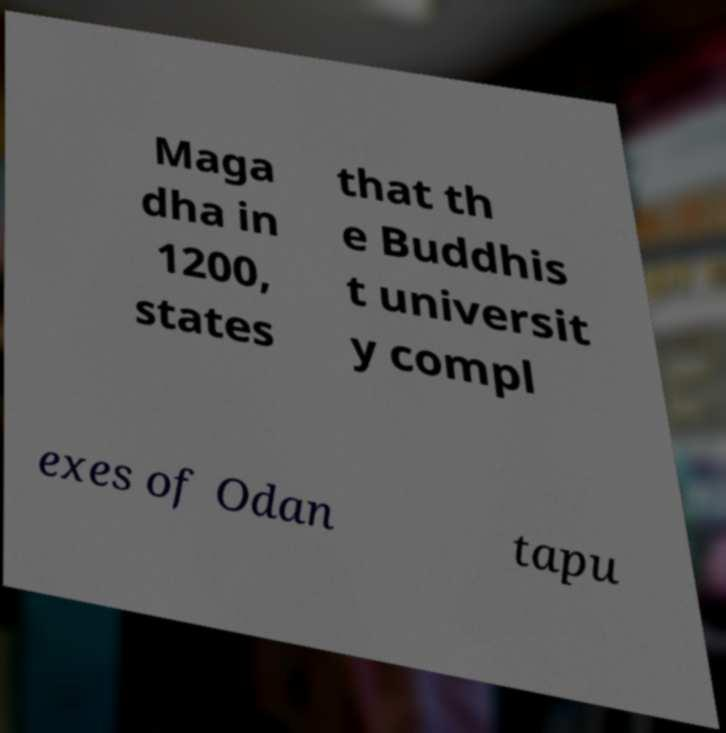Can you read and provide the text displayed in the image?This photo seems to have some interesting text. Can you extract and type it out for me? Maga dha in 1200, states that th e Buddhis t universit y compl exes of Odan tapu 